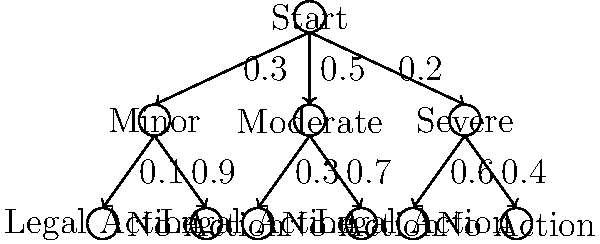Based on the decision tree above, which represents the probability of facing legal action for different severities of deceptive advertising claims, what is the overall probability of facing legal action? To calculate the overall probability of facing legal action, we need to sum the probabilities of each path leading to legal action:

1. For minor claims:
   Probability = $0.3 \times 0.1 = 0.03$

2. For moderate claims:
   Probability = $0.5 \times 0.3 = 0.15$

3. For severe claims:
   Probability = $0.2 \times 0.6 = 0.12$

The total probability is the sum of these individual probabilities:

$P(\text{Legal Action}) = 0.03 + 0.15 + 0.12 = 0.30$

Therefore, the overall probability of facing legal action is 0.30 or 30%.
Answer: 0.30 